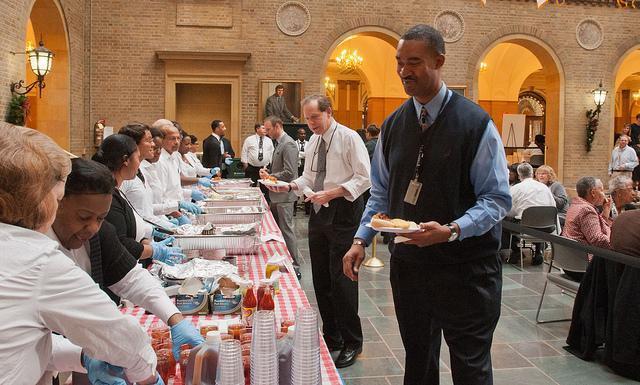How many people can be seen?
Give a very brief answer. 7. 